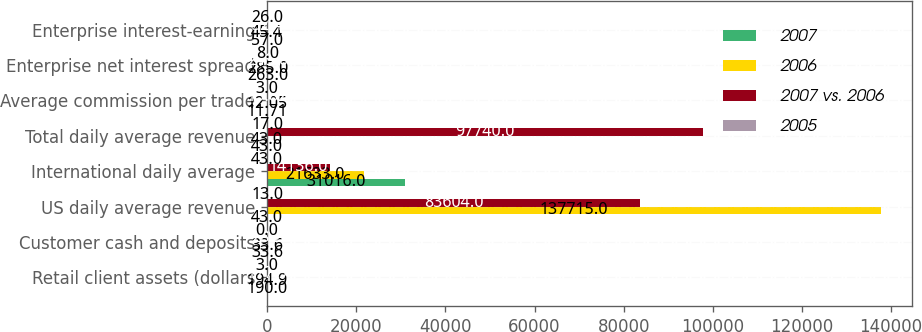<chart> <loc_0><loc_0><loc_500><loc_500><stacked_bar_chart><ecel><fcel>Retail client assets (dollars<fcel>Customer cash and deposits<fcel>US daily average revenue<fcel>International daily average<fcel>Total daily average revenue<fcel>Average commission per trade<fcel>Enterprise net interest spread<fcel>Enterprise interest-earning<nl><fcel>2007<fcel>190<fcel>33.6<fcel>43<fcel>31016<fcel>43<fcel>11.71<fcel>263<fcel>57<nl><fcel>2006<fcel>194.9<fcel>33.6<fcel>137715<fcel>21633<fcel>43<fcel>12.05<fcel>285<fcel>45.4<nl><fcel>2007 vs. 2006<fcel>177.9<fcel>28.2<fcel>83604<fcel>14136<fcel>97740<fcel>13.82<fcel>249<fcel>32.4<nl><fcel>2005<fcel>3<fcel>0<fcel>13<fcel>43<fcel>17<fcel>3<fcel>8<fcel>26<nl></chart> 